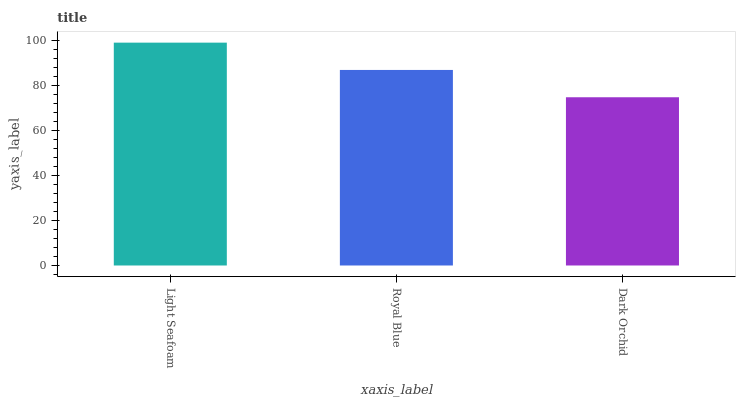Is Royal Blue the minimum?
Answer yes or no. No. Is Royal Blue the maximum?
Answer yes or no. No. Is Light Seafoam greater than Royal Blue?
Answer yes or no. Yes. Is Royal Blue less than Light Seafoam?
Answer yes or no. Yes. Is Royal Blue greater than Light Seafoam?
Answer yes or no. No. Is Light Seafoam less than Royal Blue?
Answer yes or no. No. Is Royal Blue the high median?
Answer yes or no. Yes. Is Royal Blue the low median?
Answer yes or no. Yes. Is Dark Orchid the high median?
Answer yes or no. No. Is Light Seafoam the low median?
Answer yes or no. No. 